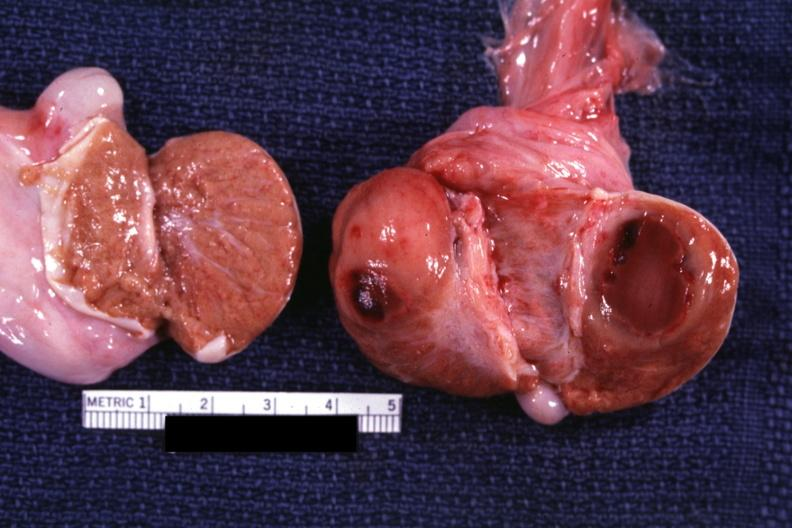s testicle present?
Answer the question using a single word or phrase. Yes 